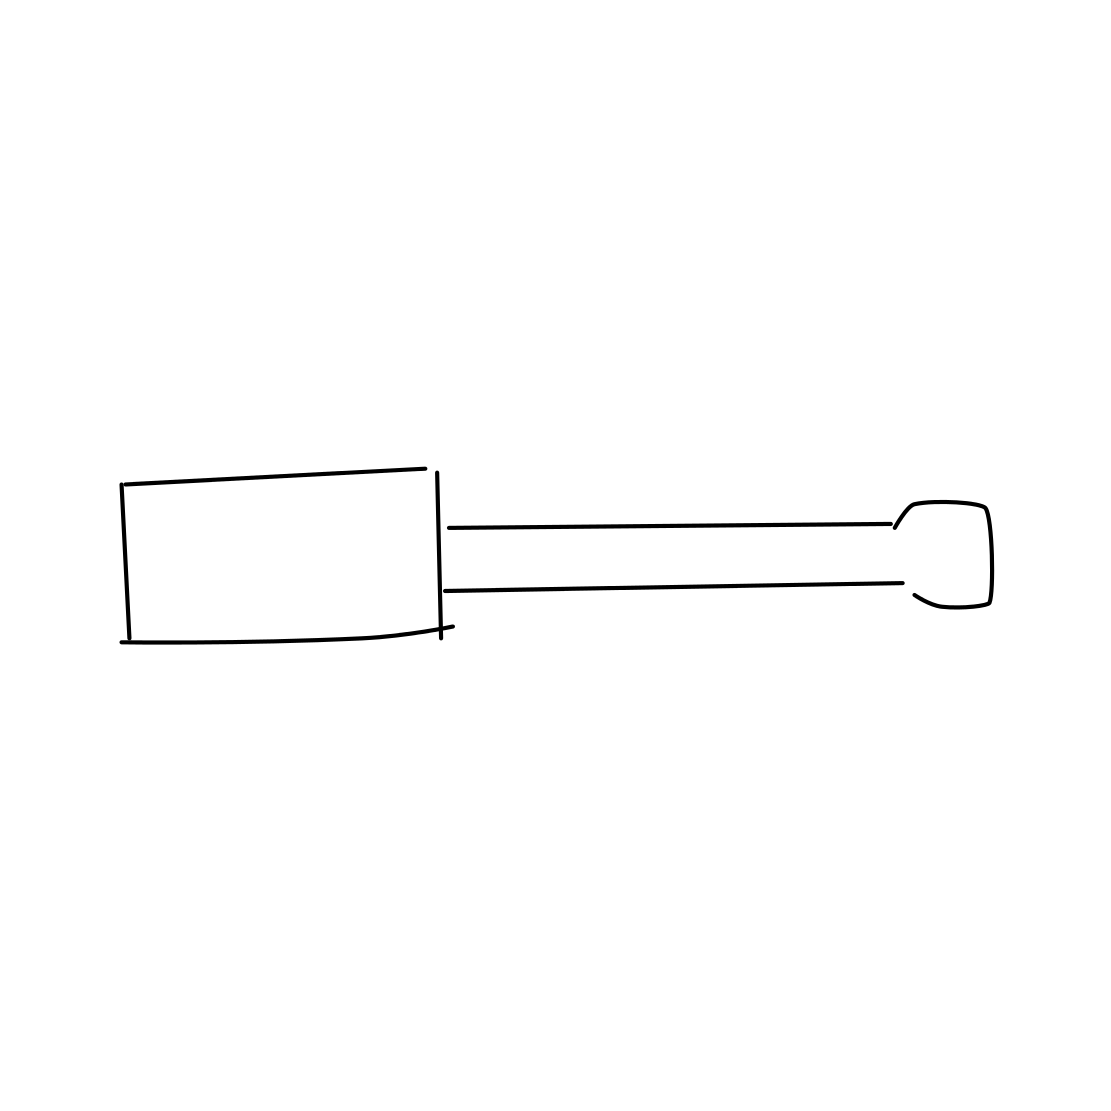In the scene, is a screwdriver in it? Yes, there is a screwdriver in the image. It has a flat head and a long handle, positioned toward the right side of the frame. This tool appears to be a standard size and could be used for various household or mechanical repairs. 